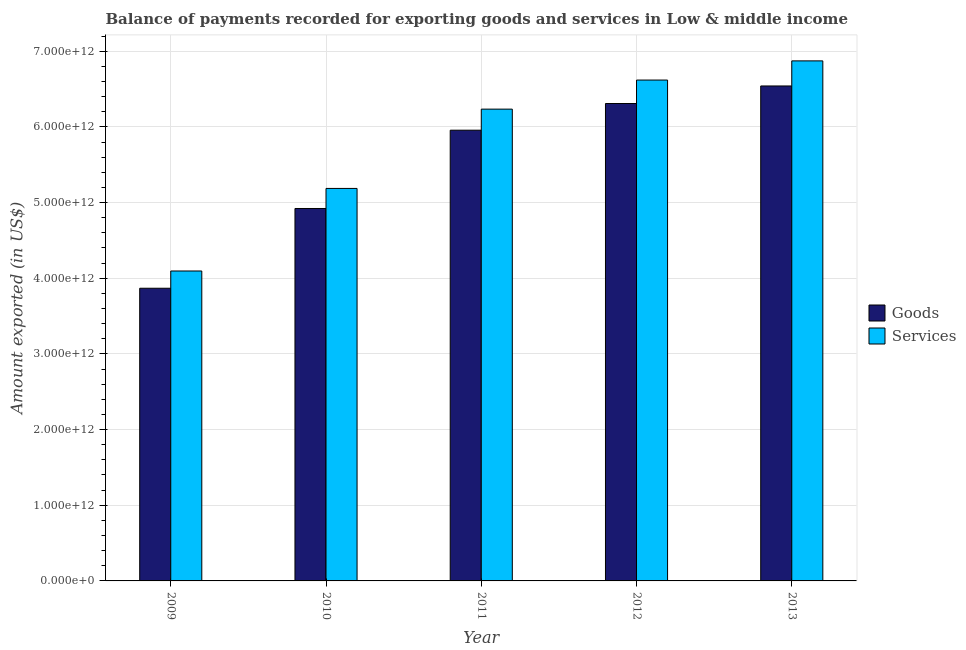How many different coloured bars are there?
Provide a short and direct response. 2. Are the number of bars per tick equal to the number of legend labels?
Your response must be concise. Yes. Are the number of bars on each tick of the X-axis equal?
Your answer should be very brief. Yes. How many bars are there on the 3rd tick from the left?
Give a very brief answer. 2. How many bars are there on the 1st tick from the right?
Provide a short and direct response. 2. What is the label of the 4th group of bars from the left?
Offer a very short reply. 2012. What is the amount of services exported in 2013?
Provide a short and direct response. 6.87e+12. Across all years, what is the maximum amount of services exported?
Offer a terse response. 6.87e+12. Across all years, what is the minimum amount of goods exported?
Your answer should be compact. 3.87e+12. In which year was the amount of goods exported maximum?
Give a very brief answer. 2013. In which year was the amount of goods exported minimum?
Ensure brevity in your answer.  2009. What is the total amount of goods exported in the graph?
Your response must be concise. 2.76e+13. What is the difference between the amount of services exported in 2010 and that in 2012?
Your response must be concise. -1.43e+12. What is the difference between the amount of goods exported in 2013 and the amount of services exported in 2012?
Provide a succinct answer. 2.32e+11. What is the average amount of goods exported per year?
Ensure brevity in your answer.  5.52e+12. In the year 2009, what is the difference between the amount of services exported and amount of goods exported?
Provide a succinct answer. 0. What is the ratio of the amount of services exported in 2011 to that in 2012?
Make the answer very short. 0.94. Is the amount of goods exported in 2012 less than that in 2013?
Ensure brevity in your answer.  Yes. Is the difference between the amount of goods exported in 2009 and 2010 greater than the difference between the amount of services exported in 2009 and 2010?
Your answer should be compact. No. What is the difference between the highest and the second highest amount of goods exported?
Offer a very short reply. 2.32e+11. What is the difference between the highest and the lowest amount of goods exported?
Offer a terse response. 2.67e+12. Is the sum of the amount of goods exported in 2009 and 2011 greater than the maximum amount of services exported across all years?
Give a very brief answer. Yes. What does the 1st bar from the left in 2012 represents?
Give a very brief answer. Goods. What does the 2nd bar from the right in 2009 represents?
Provide a short and direct response. Goods. How many bars are there?
Ensure brevity in your answer.  10. Are all the bars in the graph horizontal?
Give a very brief answer. No. What is the difference between two consecutive major ticks on the Y-axis?
Offer a very short reply. 1.00e+12. Are the values on the major ticks of Y-axis written in scientific E-notation?
Your answer should be very brief. Yes. Where does the legend appear in the graph?
Your answer should be compact. Center right. What is the title of the graph?
Make the answer very short. Balance of payments recorded for exporting goods and services in Low & middle income. Does "Lower secondary rate" appear as one of the legend labels in the graph?
Ensure brevity in your answer.  No. What is the label or title of the X-axis?
Keep it short and to the point. Year. What is the label or title of the Y-axis?
Your response must be concise. Amount exported (in US$). What is the Amount exported (in US$) in Goods in 2009?
Offer a very short reply. 3.87e+12. What is the Amount exported (in US$) of Services in 2009?
Provide a succinct answer. 4.10e+12. What is the Amount exported (in US$) of Goods in 2010?
Give a very brief answer. 4.92e+12. What is the Amount exported (in US$) of Services in 2010?
Give a very brief answer. 5.19e+12. What is the Amount exported (in US$) in Goods in 2011?
Ensure brevity in your answer.  5.96e+12. What is the Amount exported (in US$) in Services in 2011?
Offer a terse response. 6.23e+12. What is the Amount exported (in US$) in Goods in 2012?
Provide a short and direct response. 6.31e+12. What is the Amount exported (in US$) in Services in 2012?
Provide a short and direct response. 6.62e+12. What is the Amount exported (in US$) of Goods in 2013?
Provide a succinct answer. 6.54e+12. What is the Amount exported (in US$) in Services in 2013?
Provide a succinct answer. 6.87e+12. Across all years, what is the maximum Amount exported (in US$) in Goods?
Give a very brief answer. 6.54e+12. Across all years, what is the maximum Amount exported (in US$) in Services?
Provide a short and direct response. 6.87e+12. Across all years, what is the minimum Amount exported (in US$) of Goods?
Your answer should be very brief. 3.87e+12. Across all years, what is the minimum Amount exported (in US$) of Services?
Provide a succinct answer. 4.10e+12. What is the total Amount exported (in US$) of Goods in the graph?
Ensure brevity in your answer.  2.76e+13. What is the total Amount exported (in US$) of Services in the graph?
Your answer should be compact. 2.90e+13. What is the difference between the Amount exported (in US$) of Goods in 2009 and that in 2010?
Keep it short and to the point. -1.05e+12. What is the difference between the Amount exported (in US$) of Services in 2009 and that in 2010?
Offer a very short reply. -1.09e+12. What is the difference between the Amount exported (in US$) in Goods in 2009 and that in 2011?
Ensure brevity in your answer.  -2.09e+12. What is the difference between the Amount exported (in US$) of Services in 2009 and that in 2011?
Give a very brief answer. -2.14e+12. What is the difference between the Amount exported (in US$) of Goods in 2009 and that in 2012?
Make the answer very short. -2.44e+12. What is the difference between the Amount exported (in US$) of Services in 2009 and that in 2012?
Your response must be concise. -2.52e+12. What is the difference between the Amount exported (in US$) of Goods in 2009 and that in 2013?
Ensure brevity in your answer.  -2.67e+12. What is the difference between the Amount exported (in US$) in Services in 2009 and that in 2013?
Your answer should be compact. -2.78e+12. What is the difference between the Amount exported (in US$) of Goods in 2010 and that in 2011?
Offer a terse response. -1.03e+12. What is the difference between the Amount exported (in US$) in Services in 2010 and that in 2011?
Provide a succinct answer. -1.05e+12. What is the difference between the Amount exported (in US$) of Goods in 2010 and that in 2012?
Your response must be concise. -1.39e+12. What is the difference between the Amount exported (in US$) of Services in 2010 and that in 2012?
Provide a succinct answer. -1.43e+12. What is the difference between the Amount exported (in US$) in Goods in 2010 and that in 2013?
Your answer should be compact. -1.62e+12. What is the difference between the Amount exported (in US$) in Services in 2010 and that in 2013?
Make the answer very short. -1.69e+12. What is the difference between the Amount exported (in US$) in Goods in 2011 and that in 2012?
Keep it short and to the point. -3.53e+11. What is the difference between the Amount exported (in US$) in Services in 2011 and that in 2012?
Give a very brief answer. -3.84e+11. What is the difference between the Amount exported (in US$) in Goods in 2011 and that in 2013?
Offer a very short reply. -5.84e+11. What is the difference between the Amount exported (in US$) of Services in 2011 and that in 2013?
Give a very brief answer. -6.38e+11. What is the difference between the Amount exported (in US$) of Goods in 2012 and that in 2013?
Provide a short and direct response. -2.32e+11. What is the difference between the Amount exported (in US$) of Services in 2012 and that in 2013?
Give a very brief answer. -2.53e+11. What is the difference between the Amount exported (in US$) in Goods in 2009 and the Amount exported (in US$) in Services in 2010?
Offer a very short reply. -1.32e+12. What is the difference between the Amount exported (in US$) of Goods in 2009 and the Amount exported (in US$) of Services in 2011?
Your answer should be very brief. -2.37e+12. What is the difference between the Amount exported (in US$) of Goods in 2009 and the Amount exported (in US$) of Services in 2012?
Make the answer very short. -2.75e+12. What is the difference between the Amount exported (in US$) in Goods in 2009 and the Amount exported (in US$) in Services in 2013?
Ensure brevity in your answer.  -3.00e+12. What is the difference between the Amount exported (in US$) in Goods in 2010 and the Amount exported (in US$) in Services in 2011?
Offer a very short reply. -1.31e+12. What is the difference between the Amount exported (in US$) in Goods in 2010 and the Amount exported (in US$) in Services in 2012?
Offer a very short reply. -1.70e+12. What is the difference between the Amount exported (in US$) in Goods in 2010 and the Amount exported (in US$) in Services in 2013?
Your answer should be compact. -1.95e+12. What is the difference between the Amount exported (in US$) of Goods in 2011 and the Amount exported (in US$) of Services in 2012?
Your answer should be compact. -6.63e+11. What is the difference between the Amount exported (in US$) of Goods in 2011 and the Amount exported (in US$) of Services in 2013?
Give a very brief answer. -9.16e+11. What is the difference between the Amount exported (in US$) of Goods in 2012 and the Amount exported (in US$) of Services in 2013?
Your answer should be very brief. -5.63e+11. What is the average Amount exported (in US$) of Goods per year?
Offer a terse response. 5.52e+12. What is the average Amount exported (in US$) of Services per year?
Your answer should be compact. 5.80e+12. In the year 2009, what is the difference between the Amount exported (in US$) of Goods and Amount exported (in US$) of Services?
Provide a succinct answer. -2.28e+11. In the year 2010, what is the difference between the Amount exported (in US$) in Goods and Amount exported (in US$) in Services?
Offer a very short reply. -2.65e+11. In the year 2011, what is the difference between the Amount exported (in US$) in Goods and Amount exported (in US$) in Services?
Make the answer very short. -2.78e+11. In the year 2012, what is the difference between the Amount exported (in US$) of Goods and Amount exported (in US$) of Services?
Your answer should be very brief. -3.10e+11. In the year 2013, what is the difference between the Amount exported (in US$) in Goods and Amount exported (in US$) in Services?
Your answer should be compact. -3.32e+11. What is the ratio of the Amount exported (in US$) in Goods in 2009 to that in 2010?
Your answer should be compact. 0.79. What is the ratio of the Amount exported (in US$) in Services in 2009 to that in 2010?
Give a very brief answer. 0.79. What is the ratio of the Amount exported (in US$) in Goods in 2009 to that in 2011?
Your response must be concise. 0.65. What is the ratio of the Amount exported (in US$) in Services in 2009 to that in 2011?
Provide a succinct answer. 0.66. What is the ratio of the Amount exported (in US$) of Goods in 2009 to that in 2012?
Give a very brief answer. 0.61. What is the ratio of the Amount exported (in US$) in Services in 2009 to that in 2012?
Provide a succinct answer. 0.62. What is the ratio of the Amount exported (in US$) of Goods in 2009 to that in 2013?
Provide a short and direct response. 0.59. What is the ratio of the Amount exported (in US$) of Services in 2009 to that in 2013?
Provide a succinct answer. 0.6. What is the ratio of the Amount exported (in US$) in Goods in 2010 to that in 2011?
Offer a terse response. 0.83. What is the ratio of the Amount exported (in US$) of Services in 2010 to that in 2011?
Give a very brief answer. 0.83. What is the ratio of the Amount exported (in US$) of Goods in 2010 to that in 2012?
Make the answer very short. 0.78. What is the ratio of the Amount exported (in US$) of Services in 2010 to that in 2012?
Give a very brief answer. 0.78. What is the ratio of the Amount exported (in US$) in Goods in 2010 to that in 2013?
Ensure brevity in your answer.  0.75. What is the ratio of the Amount exported (in US$) of Services in 2010 to that in 2013?
Keep it short and to the point. 0.75. What is the ratio of the Amount exported (in US$) of Goods in 2011 to that in 2012?
Your answer should be very brief. 0.94. What is the ratio of the Amount exported (in US$) of Services in 2011 to that in 2012?
Your answer should be compact. 0.94. What is the ratio of the Amount exported (in US$) in Goods in 2011 to that in 2013?
Your response must be concise. 0.91. What is the ratio of the Amount exported (in US$) in Services in 2011 to that in 2013?
Offer a very short reply. 0.91. What is the ratio of the Amount exported (in US$) of Goods in 2012 to that in 2013?
Ensure brevity in your answer.  0.96. What is the ratio of the Amount exported (in US$) of Services in 2012 to that in 2013?
Your answer should be very brief. 0.96. What is the difference between the highest and the second highest Amount exported (in US$) of Goods?
Offer a terse response. 2.32e+11. What is the difference between the highest and the second highest Amount exported (in US$) in Services?
Make the answer very short. 2.53e+11. What is the difference between the highest and the lowest Amount exported (in US$) of Goods?
Your answer should be very brief. 2.67e+12. What is the difference between the highest and the lowest Amount exported (in US$) of Services?
Offer a terse response. 2.78e+12. 